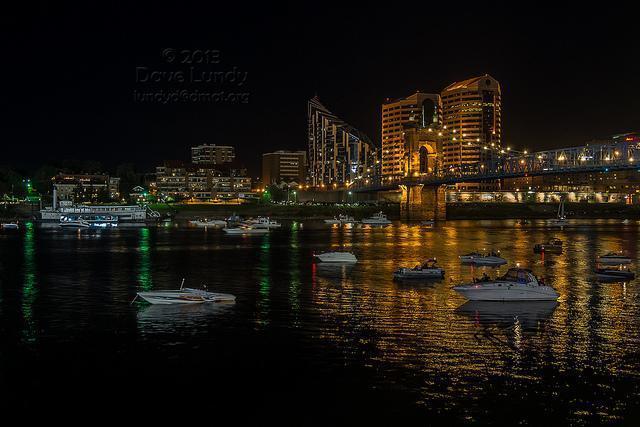How many boats are in the photo?
Give a very brief answer. 2. How many elephants are in the photo?
Give a very brief answer. 0. 